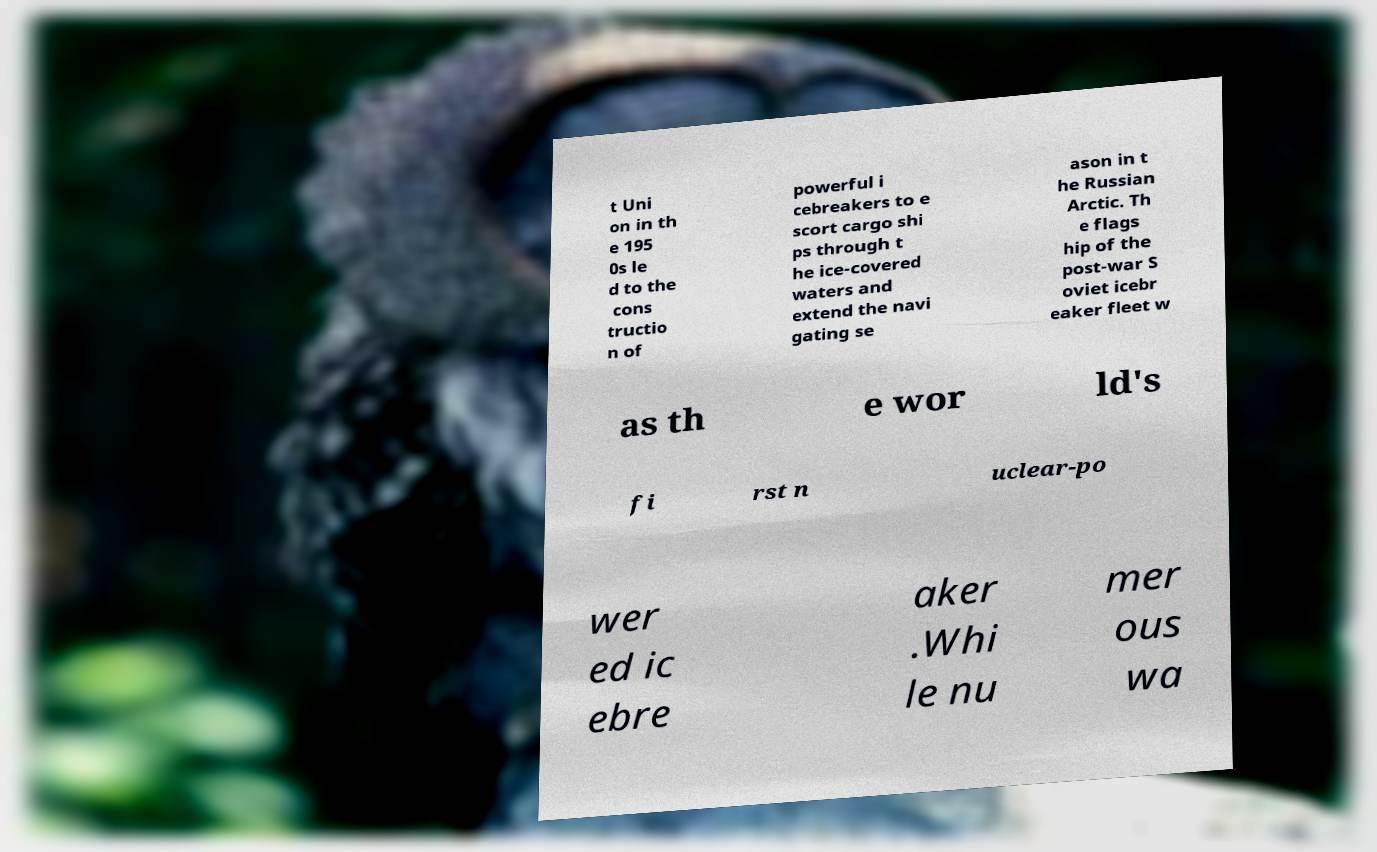Could you assist in decoding the text presented in this image and type it out clearly? t Uni on in th e 195 0s le d to the cons tructio n of powerful i cebreakers to e scort cargo shi ps through t he ice-covered waters and extend the navi gating se ason in t he Russian Arctic. Th e flags hip of the post-war S oviet icebr eaker fleet w as th e wor ld's fi rst n uclear-po wer ed ic ebre aker .Whi le nu mer ous wa 